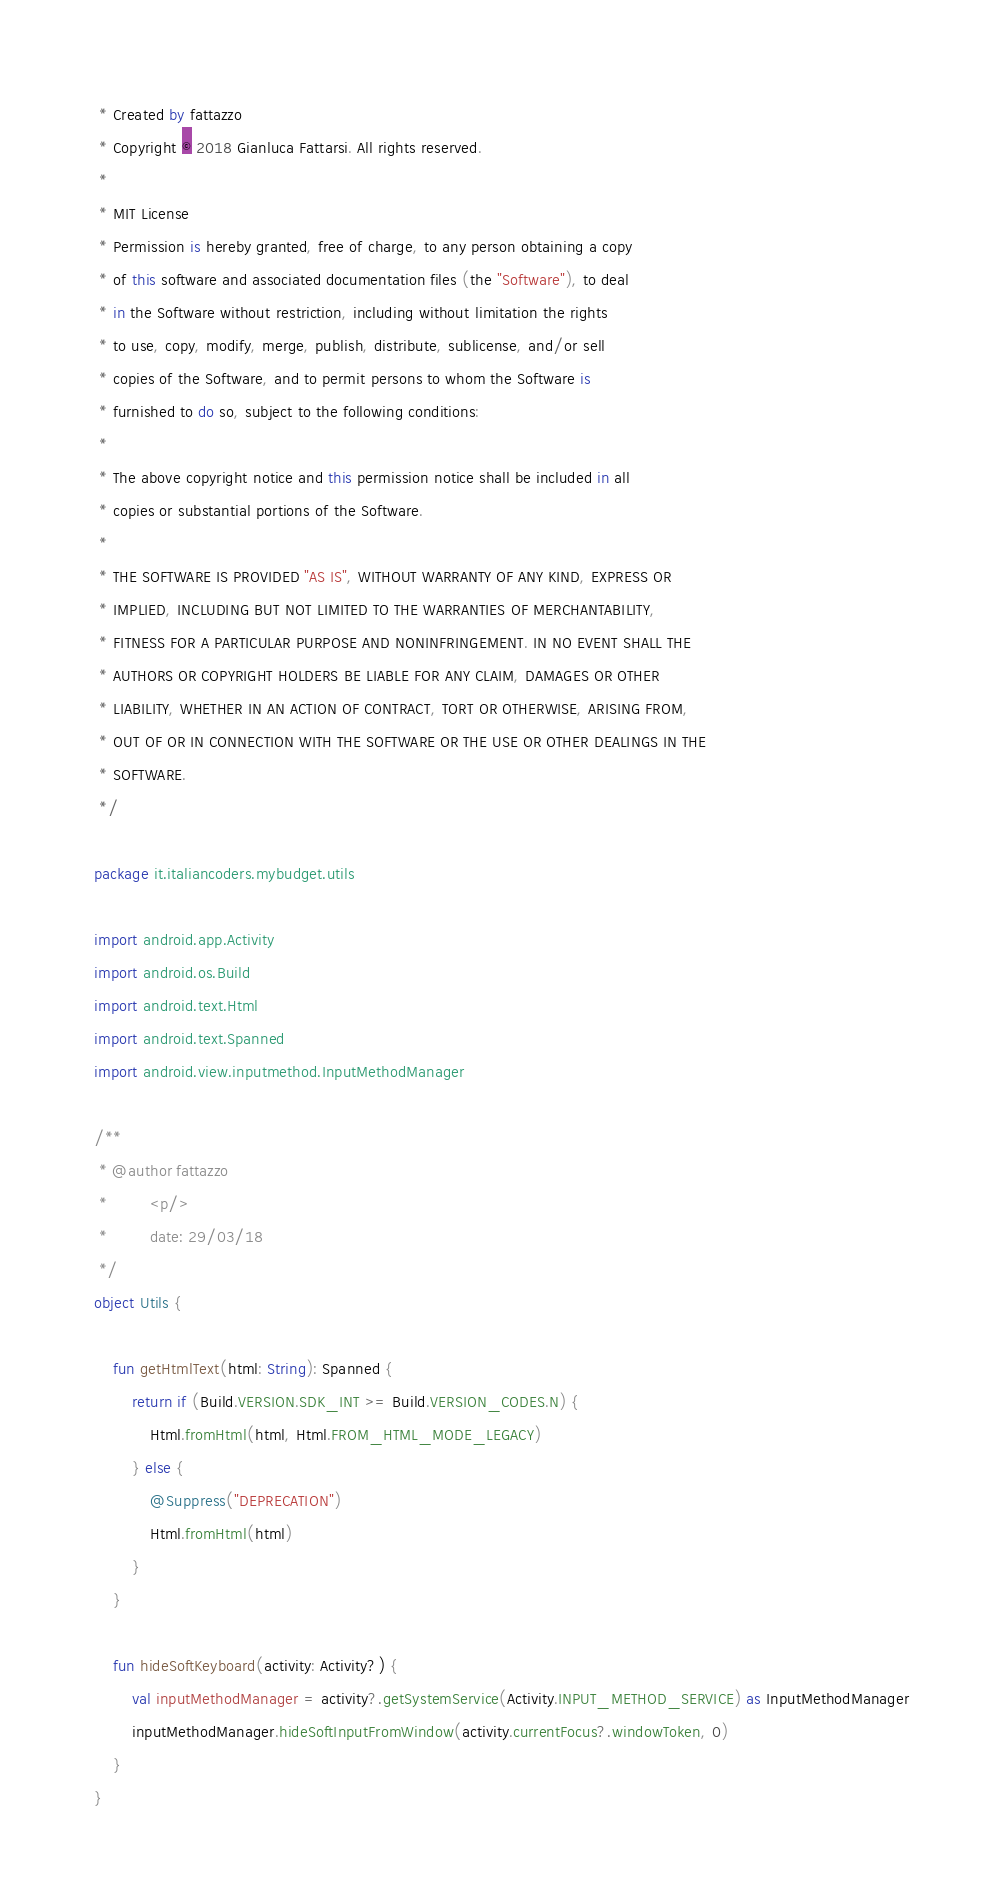<code> <loc_0><loc_0><loc_500><loc_500><_Kotlin_> * Created by fattazzo
 * Copyright © 2018 Gianluca Fattarsi. All rights reserved.
 *
 * MIT License
 * Permission is hereby granted, free of charge, to any person obtaining a copy
 * of this software and associated documentation files (the "Software"), to deal
 * in the Software without restriction, including without limitation the rights
 * to use, copy, modify, merge, publish, distribute, sublicense, and/or sell
 * copies of the Software, and to permit persons to whom the Software is
 * furnished to do so, subject to the following conditions:
 *
 * The above copyright notice and this permission notice shall be included in all
 * copies or substantial portions of the Software.
 *
 * THE SOFTWARE IS PROVIDED "AS IS", WITHOUT WARRANTY OF ANY KIND, EXPRESS OR
 * IMPLIED, INCLUDING BUT NOT LIMITED TO THE WARRANTIES OF MERCHANTABILITY,
 * FITNESS FOR A PARTICULAR PURPOSE AND NONINFRINGEMENT. IN NO EVENT SHALL THE
 * AUTHORS OR COPYRIGHT HOLDERS BE LIABLE FOR ANY CLAIM, DAMAGES OR OTHER
 * LIABILITY, WHETHER IN AN ACTION OF CONTRACT, TORT OR OTHERWISE, ARISING FROM,
 * OUT OF OR IN CONNECTION WITH THE SOFTWARE OR THE USE OR OTHER DEALINGS IN THE
 * SOFTWARE.
 */

package it.italiancoders.mybudget.utils

import android.app.Activity
import android.os.Build
import android.text.Html
import android.text.Spanned
import android.view.inputmethod.InputMethodManager

/**
 * @author fattazzo
 *         <p/>
 *         date: 29/03/18
 */
object Utils {

    fun getHtmlText(html: String): Spanned {
        return if (Build.VERSION.SDK_INT >= Build.VERSION_CODES.N) {
            Html.fromHtml(html, Html.FROM_HTML_MODE_LEGACY)
        } else {
            @Suppress("DEPRECATION")
            Html.fromHtml(html)
        }
    }

    fun hideSoftKeyboard(activity: Activity?) {
        val inputMethodManager = activity?.getSystemService(Activity.INPUT_METHOD_SERVICE) as InputMethodManager
        inputMethodManager.hideSoftInputFromWindow(activity.currentFocus?.windowToken, 0)
    }
}</code> 